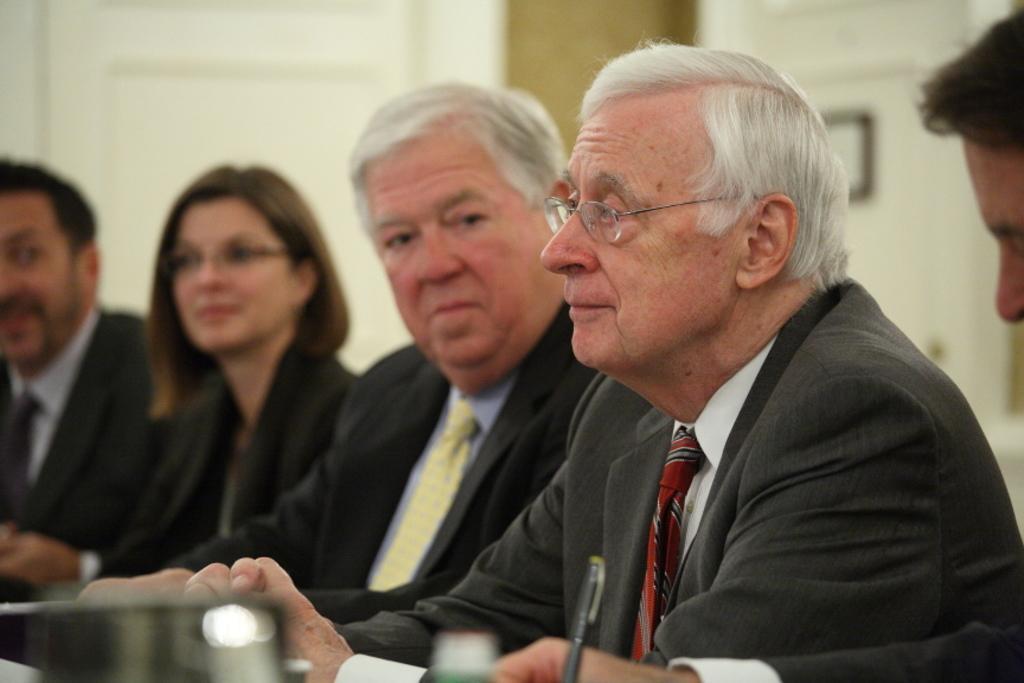Can you describe this image briefly? In the image we can see there are people sitting, they are wearing clothes and two of them are wearing spectacles. Here we can see the pen and the background is slightly blurred. 